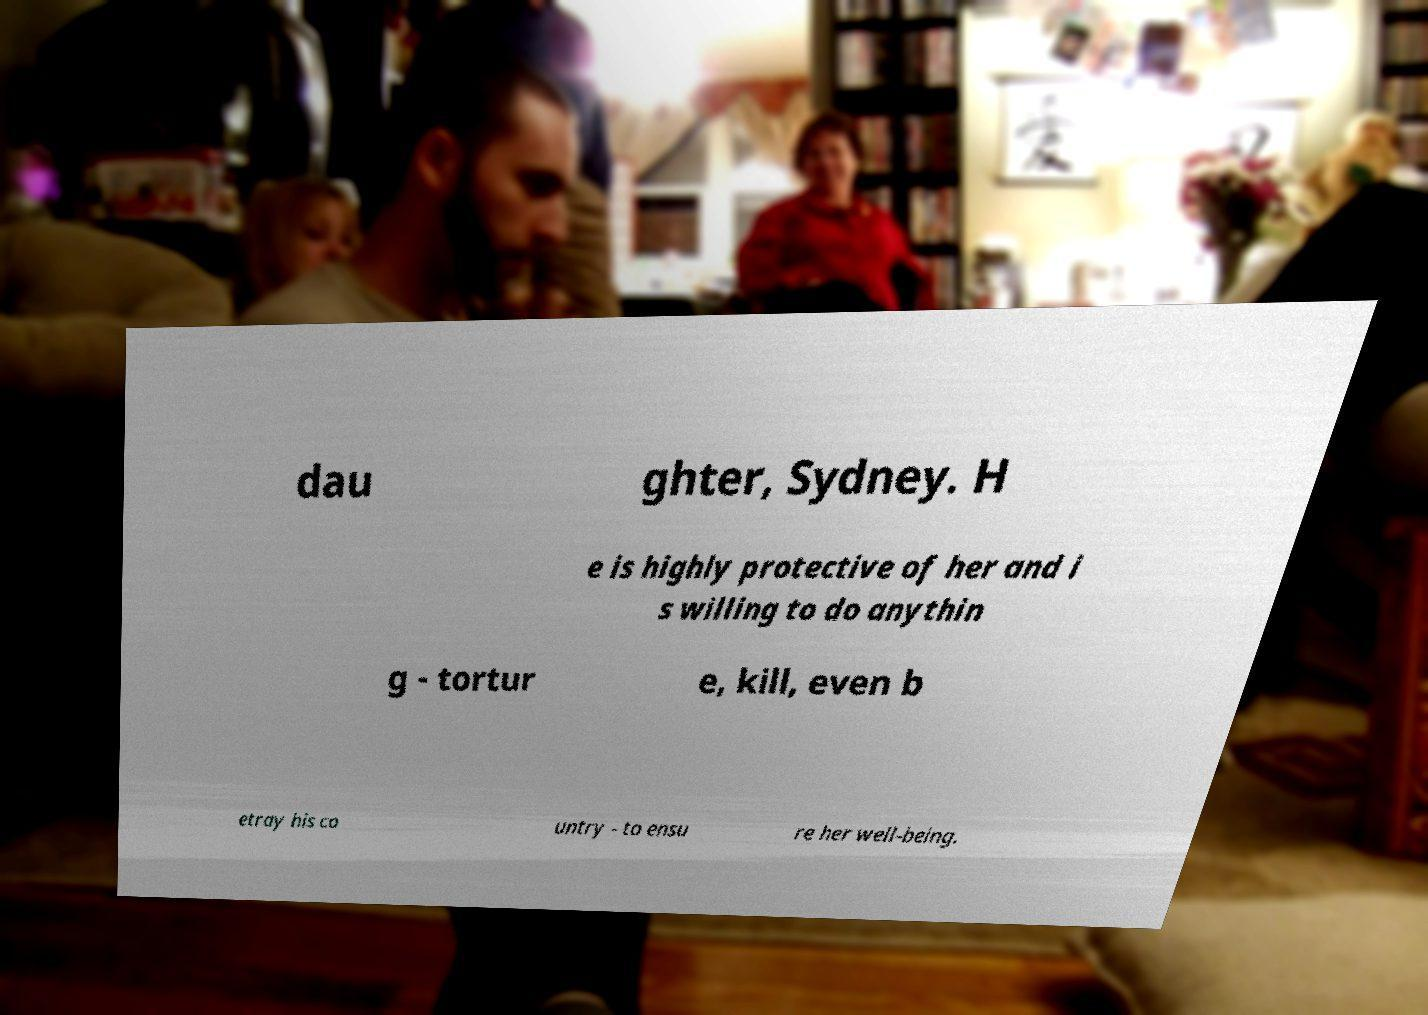Can you accurately transcribe the text from the provided image for me? dau ghter, Sydney. H e is highly protective of her and i s willing to do anythin g - tortur e, kill, even b etray his co untry - to ensu re her well-being. 